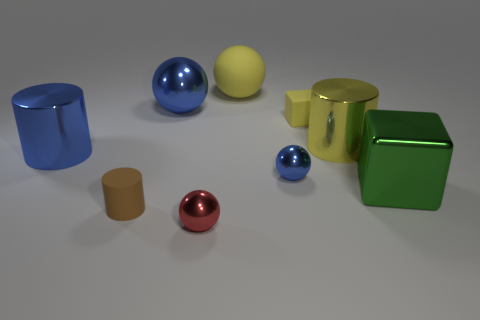Subtract all red balls. How many balls are left? 3 Subtract all big yellow balls. How many balls are left? 3 Add 1 yellow spheres. How many objects exist? 10 Subtract all cylinders. How many objects are left? 6 Subtract all cyan cubes. Subtract all red spheres. How many cubes are left? 2 Subtract all green spheres. How many green blocks are left? 1 Subtract all small red objects. Subtract all small blue metallic blocks. How many objects are left? 8 Add 8 small brown matte cylinders. How many small brown matte cylinders are left? 9 Add 7 yellow objects. How many yellow objects exist? 10 Subtract 1 green cubes. How many objects are left? 8 